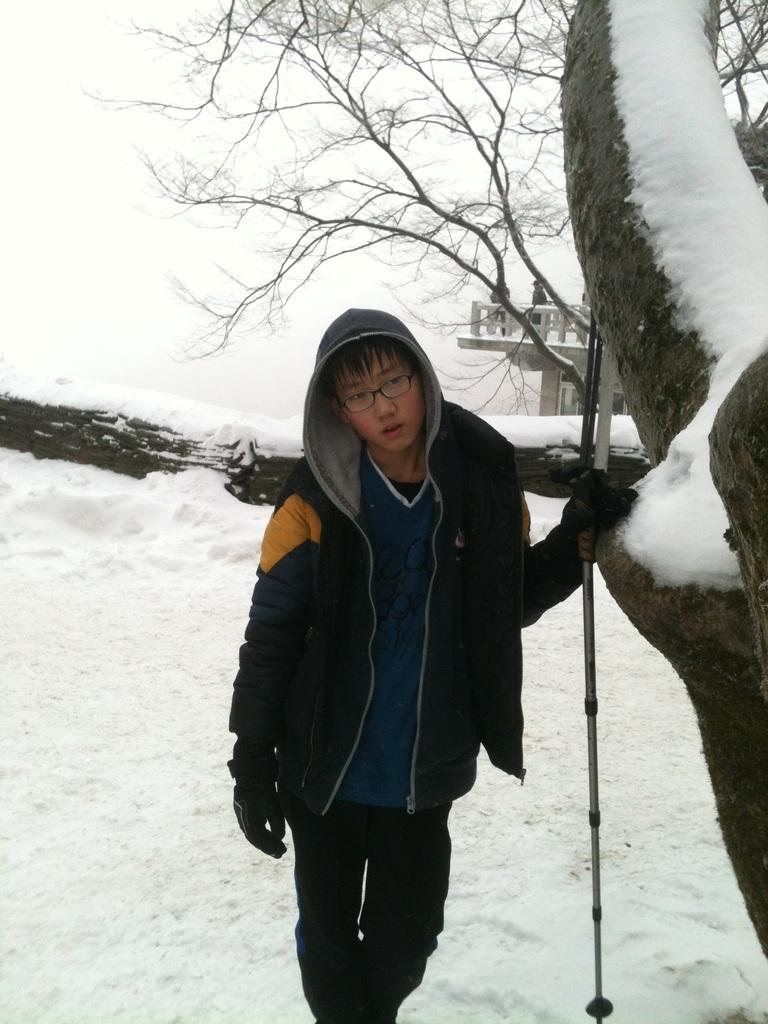Who is the main subject in the image? There is a boy in the image. What is the boy doing in the image? The boy is standing beside a tree. What is the boy holding in his hand? The boy is holding a stick in his hand. What is the condition of the land around the boy? The land around the boy is filled with snow. What can be seen in the background of the image? There is a house and a dry tree in the background of the image. What type of frame is the boy using to hold the stick in the image? There is no frame present in the image; the boy is simply holding the stick in his hand. Can you describe the clouds in the image? There are no clouds visible in the image. 